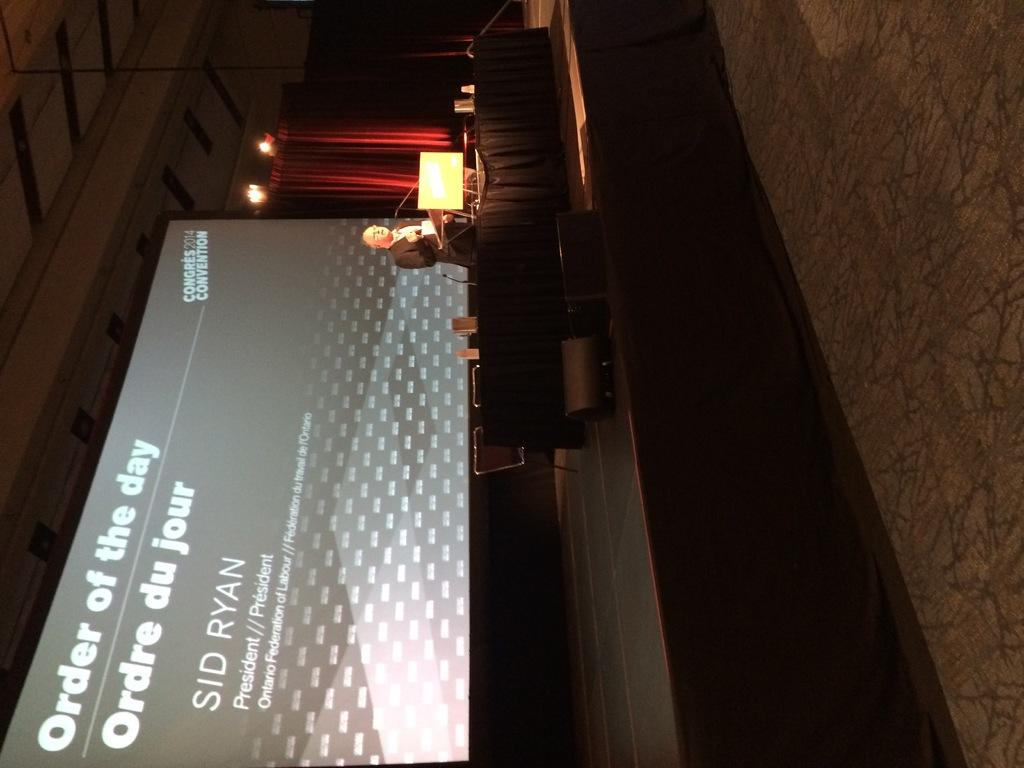What is the person doing on the stage? The person is standing on the stage. What objects can be seen on the stage besides the person? There is a black table, a microphone, a screen, and a projector display on the stage. What might the person be using to communicate with the audience? The microphone on the stage could be used for communication. What is being displayed on the screen? The provided facts do not specify what is being displayed on the screen. What type of lighting is present on the stage? There are lights at the top of the stage. What is behind the person on the stage? There are curtains behind the person. What type of book is the person holding while standing on the stage? The provided facts do not mention a book, so it cannot be determined if the person is holding one. 